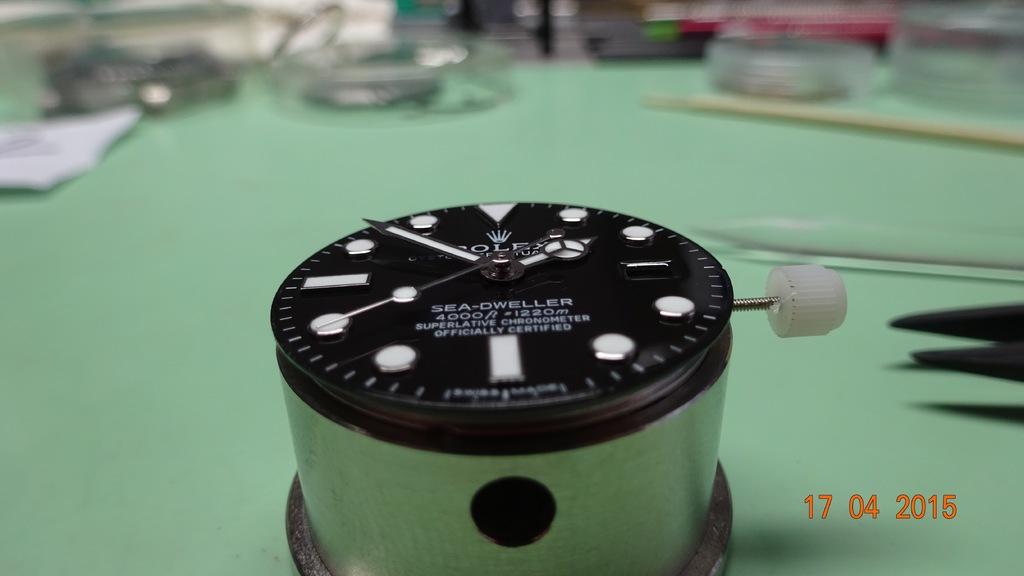When was this photo taken?
Provide a succinct answer. 17 04 2015. What time is it?
Keep it short and to the point. 1:53. 